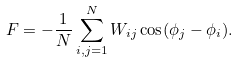Convert formula to latex. <formula><loc_0><loc_0><loc_500><loc_500>F = - \frac { 1 } { N } \sum _ { i , j = 1 } ^ { N } W _ { i j } \cos ( \phi _ { j } - \phi _ { i } ) .</formula> 